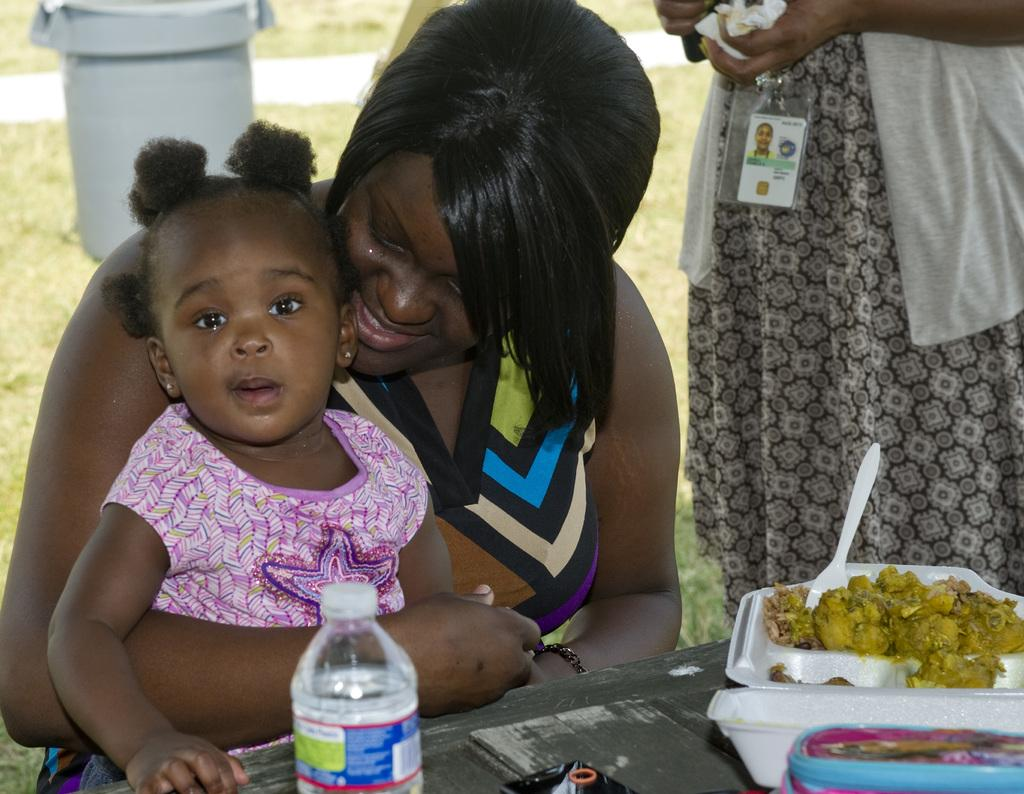How many women are present in the image? There are two women in the image, one standing and one seated. What is the seated woman doing? The seated woman is holding a girl. What can be seen on the table in the image? There is food visible on a table, as well as a water bottle. What object is present for disposing of waste in the image? There is a dustbin in the image. What song is the woman singing in the image? There is no indication in the image that the woman is singing a song. What is the wealth status of the people in the image? The image does not provide any information about the wealth status of the people. 